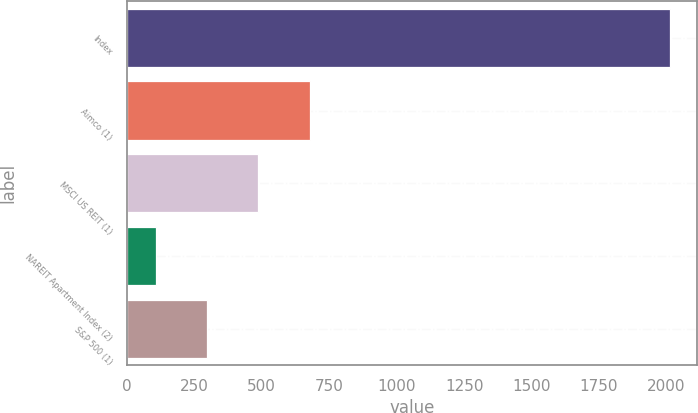Convert chart to OTSL. <chart><loc_0><loc_0><loc_500><loc_500><bar_chart><fcel>Index<fcel>Aimco (1)<fcel>MSCI US REIT (1)<fcel>NAREIT Apartment Index (2)<fcel>S&P 500 (1)<nl><fcel>2012<fcel>678.46<fcel>487.95<fcel>106.93<fcel>297.44<nl></chart> 